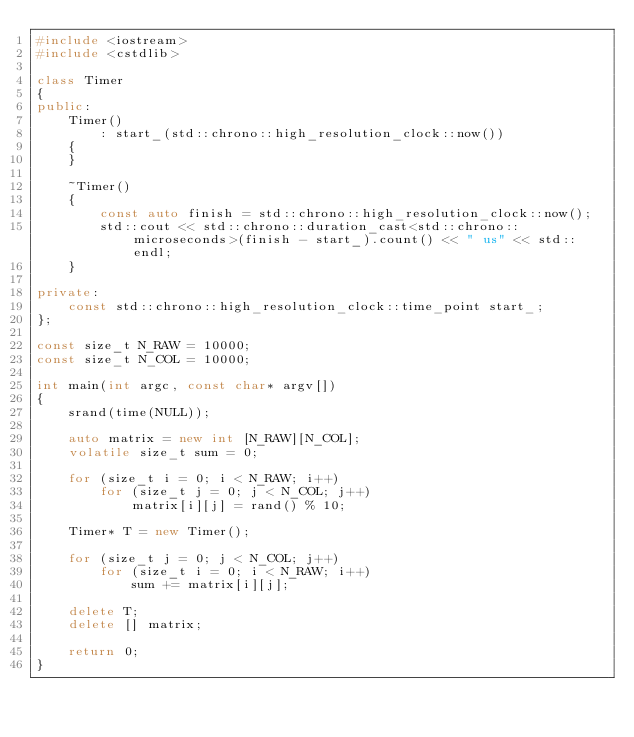<code> <loc_0><loc_0><loc_500><loc_500><_C++_>#include <iostream>
#include <cstdlib>

class Timer
{
public:
    Timer()
        : start_(std::chrono::high_resolution_clock::now())
    {
    }

    ~Timer()
    {
        const auto finish = std::chrono::high_resolution_clock::now();
        std::cout << std::chrono::duration_cast<std::chrono::microseconds>(finish - start_).count() << " us" << std::endl;
    }

private:
    const std::chrono::high_resolution_clock::time_point start_;
};

const size_t N_RAW = 10000;
const size_t N_COL = 10000;

int main(int argc, const char* argv[])
{
    srand(time(NULL));

    auto matrix = new int [N_RAW][N_COL];
    volatile size_t sum = 0;

    for (size_t i = 0; i < N_RAW; i++)
        for (size_t j = 0; j < N_COL; j++)
            matrix[i][j] = rand() % 10;

    Timer* T = new Timer();

    for (size_t j = 0; j < N_COL; j++)
        for (size_t i = 0; i < N_RAW; i++)
            sum += matrix[i][j];

    delete T;
    delete [] matrix;

    return 0;
}

</code> 